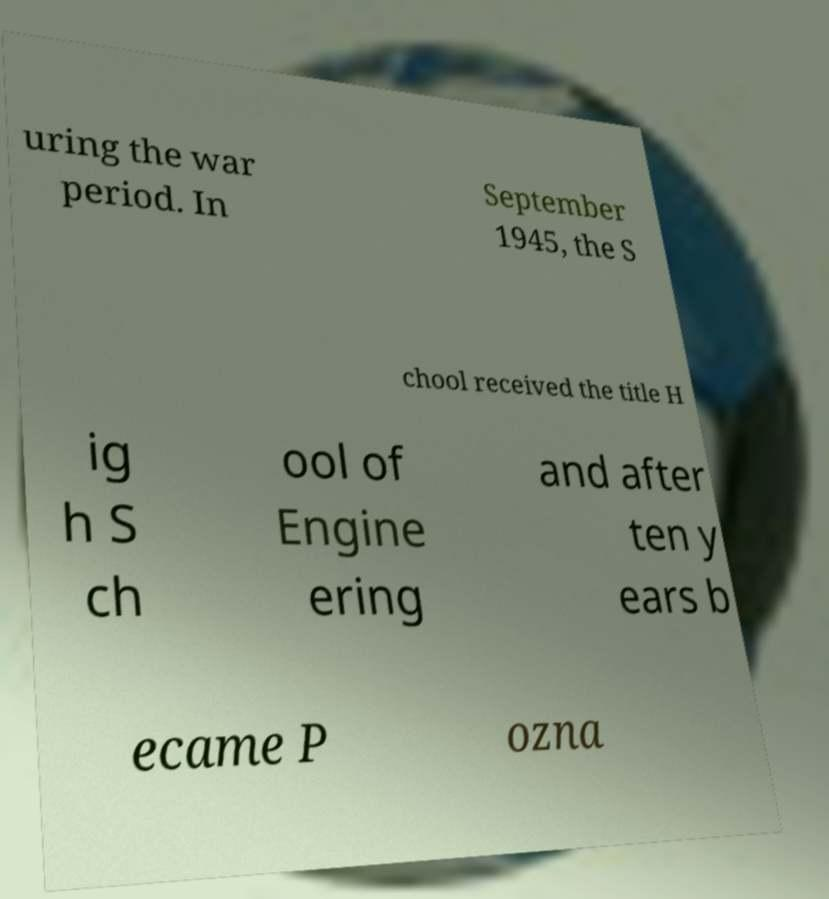Please identify and transcribe the text found in this image. uring the war period. In September 1945, the S chool received the title H ig h S ch ool of Engine ering and after ten y ears b ecame P ozna 